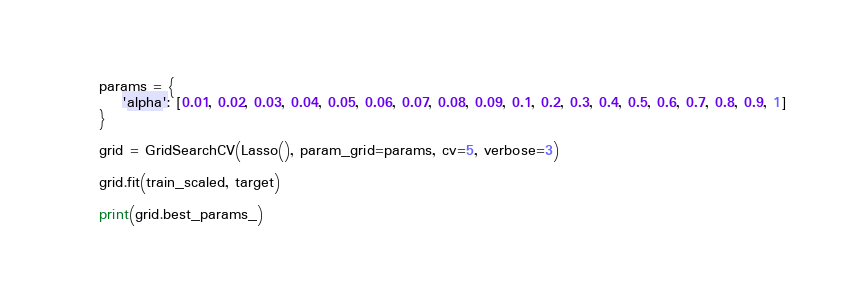<code> <loc_0><loc_0><loc_500><loc_500><_Python_>    params = {
        'alpha': [0.01, 0.02, 0.03, 0.04, 0.05, 0.06, 0.07, 0.08, 0.09, 0.1, 0.2, 0.3, 0.4, 0.5, 0.6, 0.7, 0.8, 0.9, 1]
    }

    grid = GridSearchCV(Lasso(), param_grid=params, cv=5, verbose=3)

    grid.fit(train_scaled, target)

    print(grid.best_params_)
</code> 